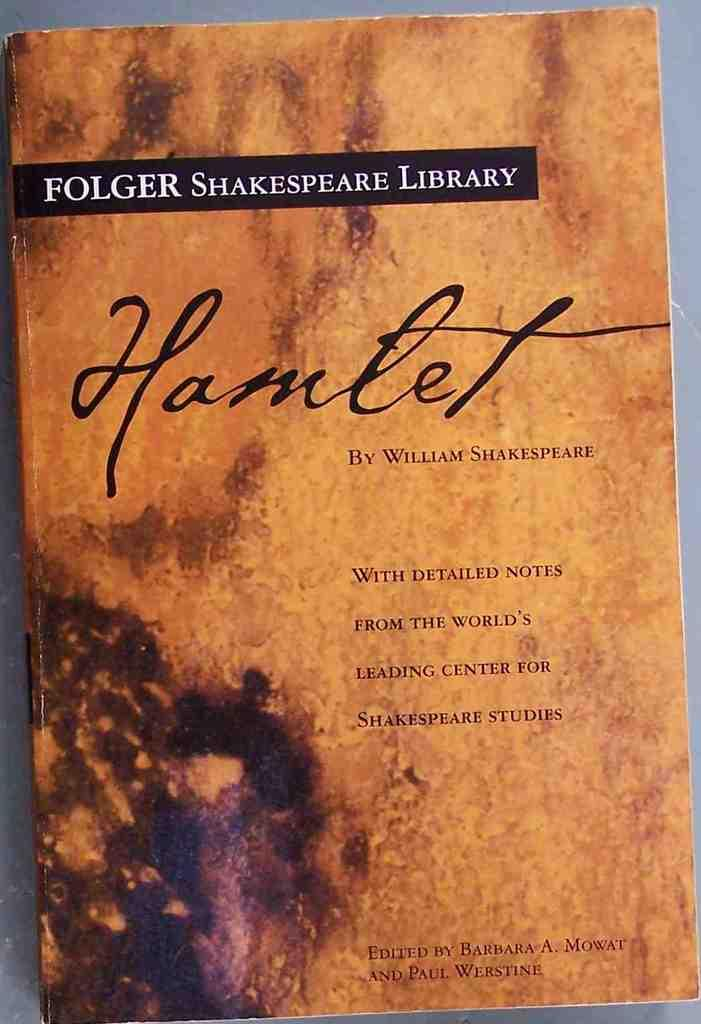Provide a one-sentence caption for the provided image. The Folger Shakespeare Library edition of the book Hamlet. 